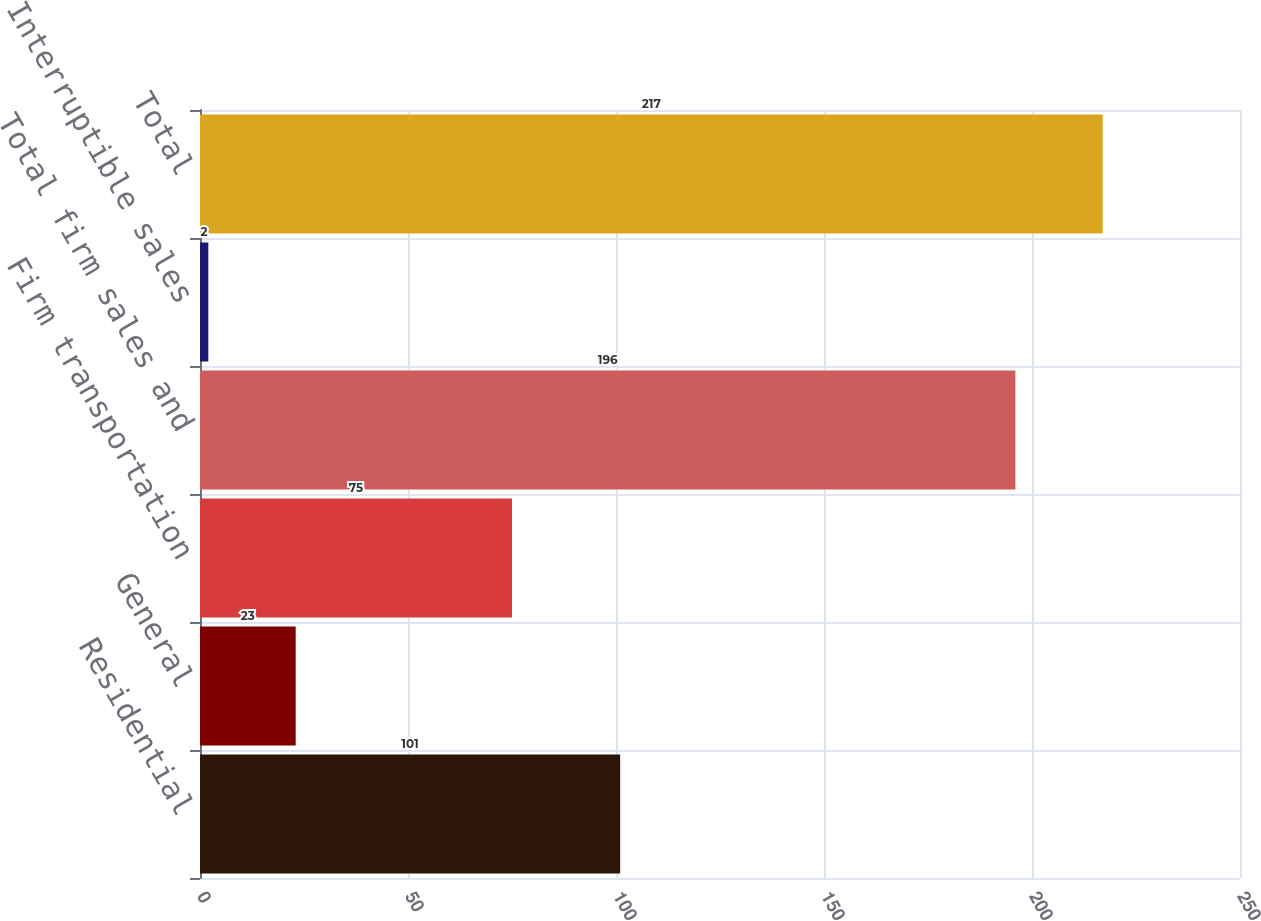<chart> <loc_0><loc_0><loc_500><loc_500><bar_chart><fcel>Residential<fcel>General<fcel>Firm transportation<fcel>Total firm sales and<fcel>Interruptible sales<fcel>Total<nl><fcel>101<fcel>23<fcel>75<fcel>196<fcel>2<fcel>217<nl></chart> 